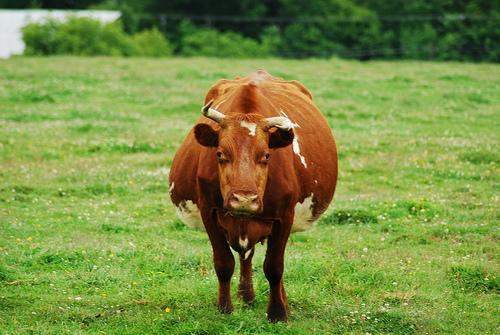Provide a brief description of the central object in the image. A brown and white cow with white spots is standing on a grassy field. Name the animal in the image and its distinguishing features. A brown and white spotted cow with a white nose, horns, and a bloated appearance. What kind of animal is in the image, and where is it located? A brown and white cow with spots is in a grassy field with flowers. Describe the animal's position in the environment and what it is doing. The cow stands on a grassy field with scattered flowers, appearing at ease. Mention the animal's main activity and the surroundings in the image. The cow stands peacefully in a field of green grass and flowers. Use three adjectives to describe the scene in the image. A calm, pastoral scene with a bloated cow standing on lush grass. State the primary subject in the image and any additional objects of interest. The primary subject is a brown and white cow with white spots, and there are yellow and white flowers in the grass. Highlight the key visual features of the primary subject in the image. The cow has a white spot on its head, a white nose, horns, and a bloated appearance. Enumerate three details about the animal's appearance in the image. 3. The cow has horns. Describe the background of the image and any secondary elements present. There are yellow and white flowers scattered across the lush green grass, with a fence visible in the distance. 